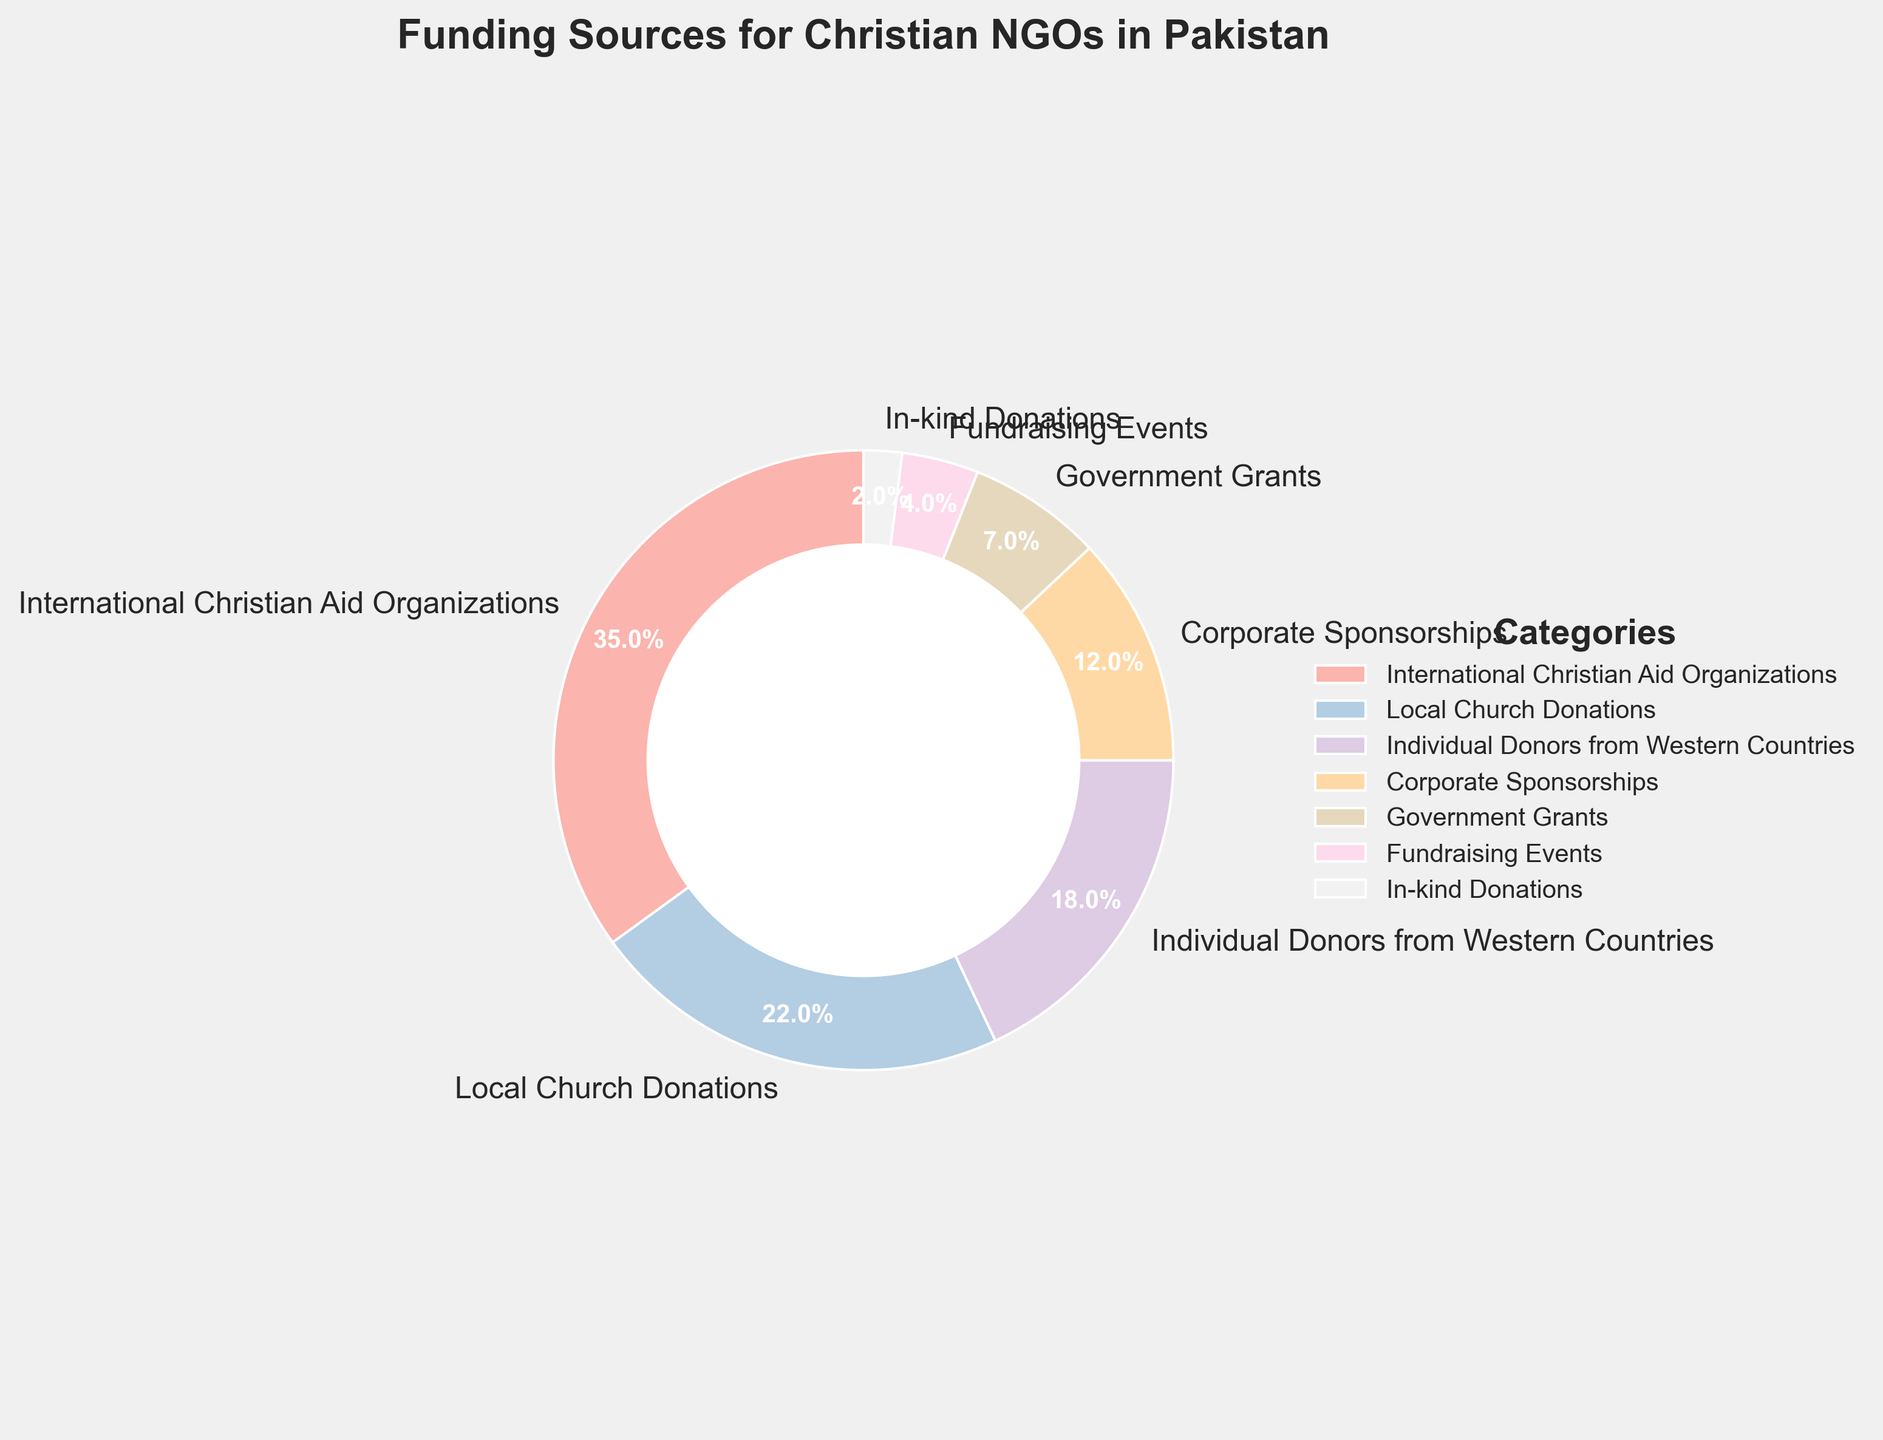What percentage of funding do International Christian Aid Organizations and Local Church Donations contribute together? To find the combined percentage, add the percentages of International Christian Aid Organizations (35%) and Local Church Donations (22%). 35% + 22% = 57%
Answer: 57% Which funding source category provides the least amount of funding? By referring to the figure, we look for the category with the smallest percentage. In-kind Donations have the smallest percentage at 2%.
Answer: In-kind Donations Is the percentage of funding from Individual Donors from Western Countries greater than Corporate Sponsorships? Compare the percentages of Individual Donors from Western Countries (18%) and Corporate Sponsorships (12%). 18% is greater than 12%.
Answer: Yes How much more percentage of funding do International Christian Aid Organizations provide compared to Government Grants? Subtract the percentage of Government Grants (7%) from the percentage of International Christian Aid Organizations (35%). 35% - 7% = 28%
Answer: 28% What is the total percentage of funding provided by categories that contribute less than 10% each? Sum the percentages of categories that contribute less than 10%: Government Grants (7%), Fundraising Events (4%), and In-kind Donations (2%). 7% + 4% + 2% = 13%
Answer: 13% Which category provides more funding: Local Church Donations or Individual Donors from Western Countries? Compare the percentages of Local Church Donations (22%) and Individual Donors from Western Countries (18%). 22% is greater than 18%.
Answer: Local Church Donations If you combine the funding percentages from Corporate Sponsorships and Fundraising Events, is the result greater than the funding from Individual Donors from Western Countries? Add the percentages of Corporate Sponsorships (12%) and Fundraising Events (4%), and compare the sum with the percentage of Individual Donors from Western Countries (18%). 12% + 4% = 16%, which is less than 18%.
Answer: No What is the percentage difference between the largest and smallest funding sources? Subtract the percentage of the smallest funding source (In-kind Donations, 2%) from the largest funding source (International Christian Aid Organizations, 35%). 35% - 2% = 33%
Answer: 33% Which categories together make up more than half of the total funding? Identify the combinations of categories that sum to more than 50%. International Christian Aid Organizations (35%) + Local Church Donations (22%) = 57% which is more than half.
Answer: International Christian Aid Organizations and Local Church Donations 